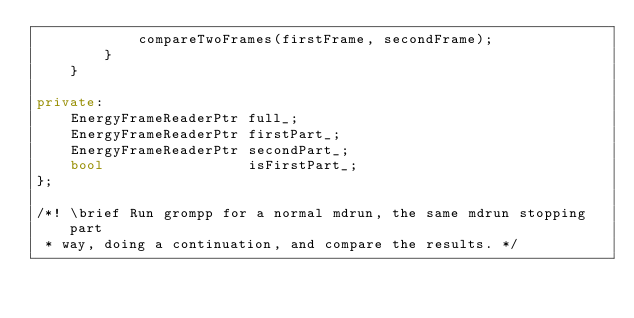Convert code to text. <code><loc_0><loc_0><loc_500><loc_500><_C++_>            compareTwoFrames(firstFrame, secondFrame);
        }
    }

private:
    EnergyFrameReaderPtr full_;
    EnergyFrameReaderPtr firstPart_;
    EnergyFrameReaderPtr secondPart_;
    bool                 isFirstPart_;
};

/*! \brief Run grompp for a normal mdrun, the same mdrun stopping part
 * way, doing a continuation, and compare the results. */</code> 